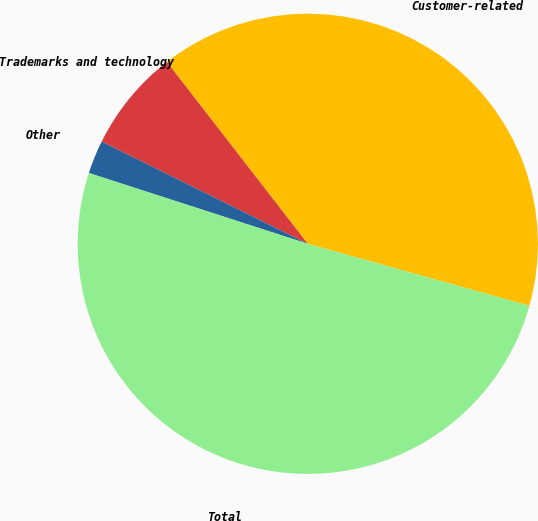<chart> <loc_0><loc_0><loc_500><loc_500><pie_chart><fcel>Customer-related<fcel>Trademarks and technology<fcel>Other<fcel>Total<nl><fcel>39.84%<fcel>7.18%<fcel>2.35%<fcel>50.64%<nl></chart> 